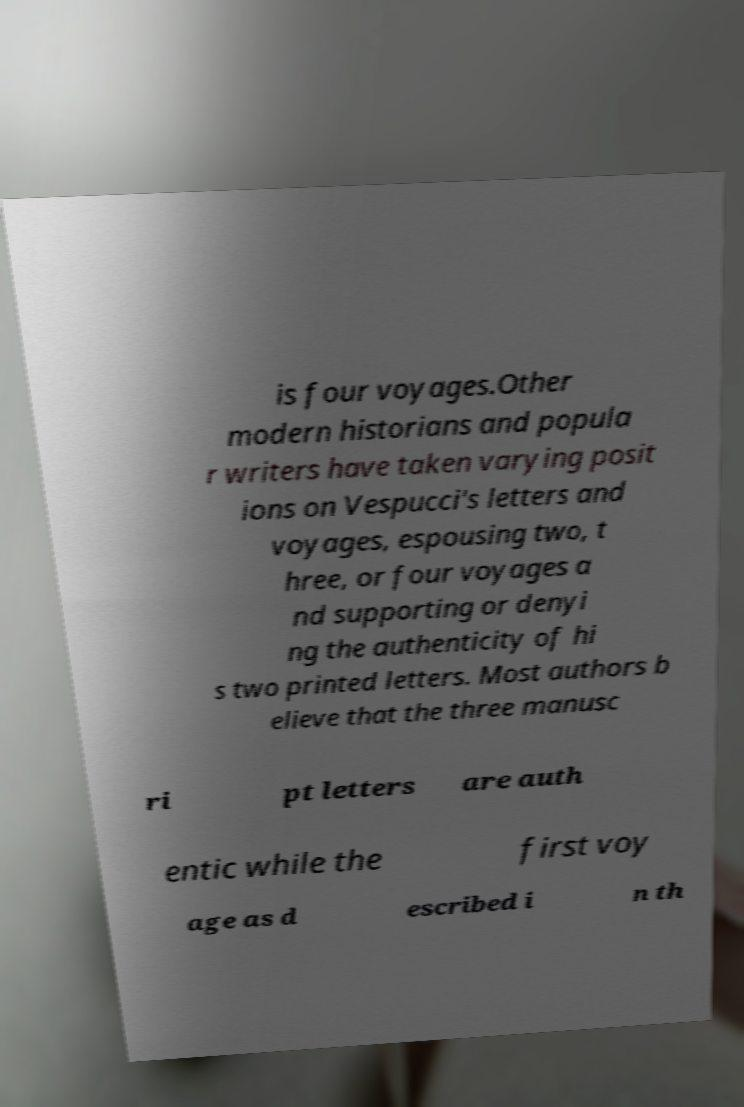Could you assist in decoding the text presented in this image and type it out clearly? is four voyages.Other modern historians and popula r writers have taken varying posit ions on Vespucci's letters and voyages, espousing two, t hree, or four voyages a nd supporting or denyi ng the authenticity of hi s two printed letters. Most authors b elieve that the three manusc ri pt letters are auth entic while the first voy age as d escribed i n th 